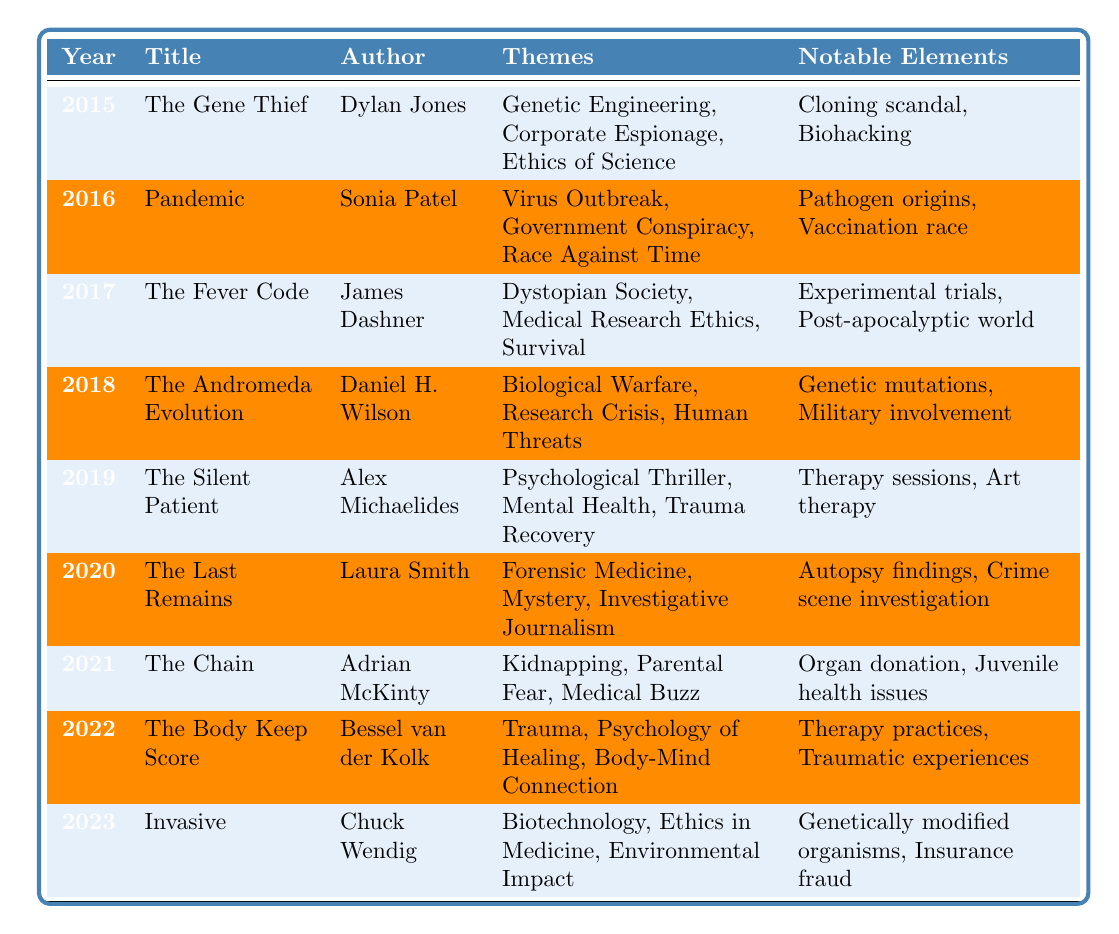What is the title of the medical thriller published in 2018? According to the table, the entry for 2018 lists "The Andromeda Evolution" as the title.
Answer: The Andromeda Evolution Who is the author of "The Silent Patient"? The table shows the author listed next to "The Silent Patient" is Alex Michaelides.
Answer: Alex Michaelides How many themes are associated with the book published in 2021? The table indicates that "The Chain" published in 2021 has three themes: Kidnapping, Parental Fear, and Medical Buzz.
Answer: 3 What notable element is mentioned for the book "Pandemic"? The notable elements listed for "Pandemic" include "Pathogen origins" and "Vaccination race", so one notable element is "Pathogen origins".
Answer: Pathogen origins Which theme appears in both "The Gene Thief" and "Invasive"? By examining the themes of both books, "Ethics of Science" in "The Gene Thief" and "Ethics in Medicine" in "Invasive" suggest an overlap in the ethical dimension.
Answer: Yes What is the most common theme across the books from 2015 to 2023? To determine the most common theme, we check each book's themes and notice that no theme appears in three or more titles. So, there is no single most common theme.
Answer: None Which book features elements of forensic medicine? The entry for the year 2020 shows that "The Last Remains" includes elements of forensic medicine.
Answer: The Last Remains How many books feature a theme related to trauma? Looking at the themes, "The Silent Patient" and "The Body Keep Score" both include trauma-related themes, thus there are two such books.
Answer: 2 Is "Biological Warfare" a theme in any book? Yes, by checking the table, we find that "The Andromeda Evolution" mentions "Biological Warfare" as one of its themes.
Answer: Yes Which year saw the publication of a book with a dystopian society theme? The year 2017 has "The Fever Code" listed, which includes "Dystopian Society" as one of its themes.
Answer: 2017 